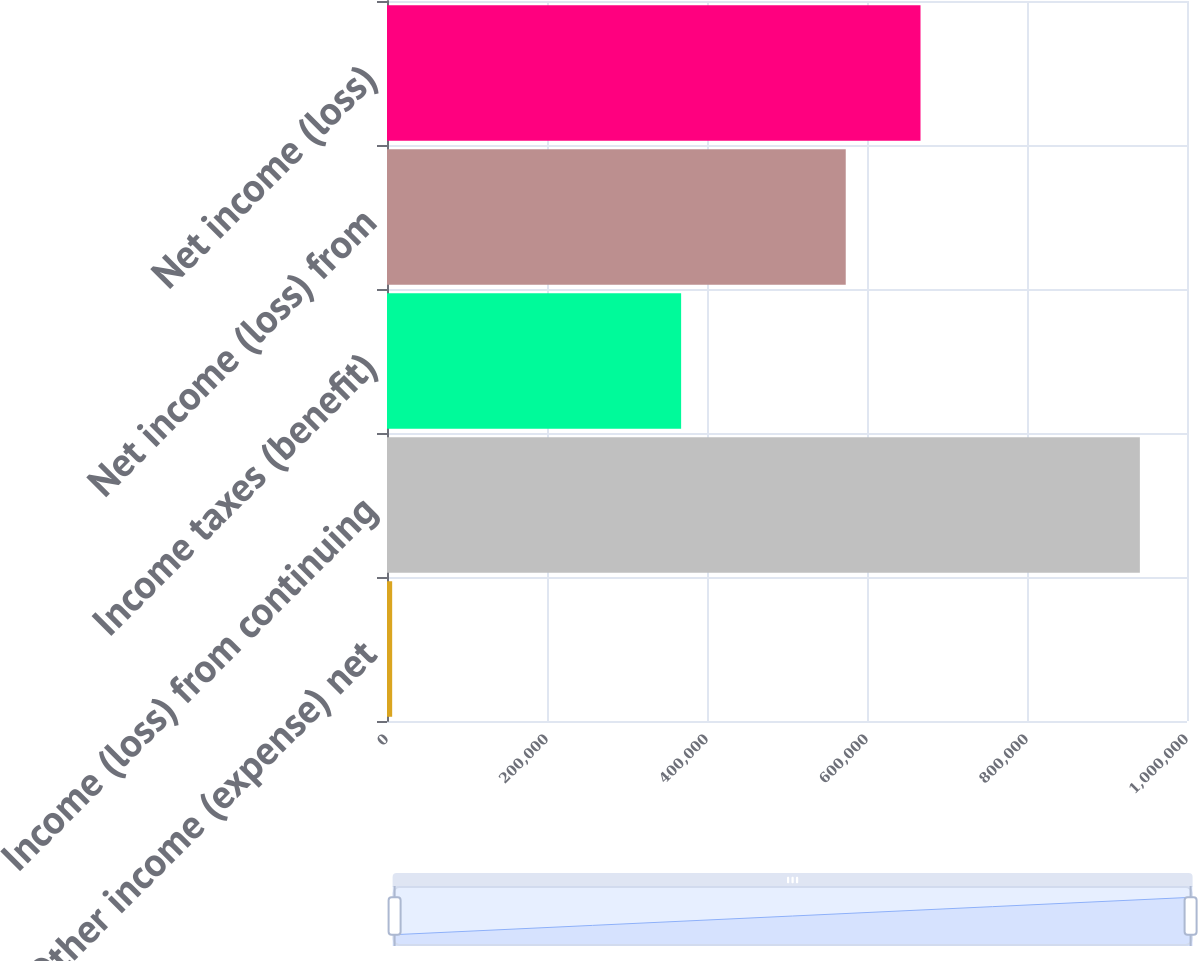Convert chart to OTSL. <chart><loc_0><loc_0><loc_500><loc_500><bar_chart><fcel>Other income (expense) net<fcel>Income (loss) from continuing<fcel>Income taxes (benefit)<fcel>Net income (loss) from<fcel>Net income (loss)<nl><fcel>6461<fcel>941090<fcel>367660<fcel>573430<fcel>666893<nl></chart> 